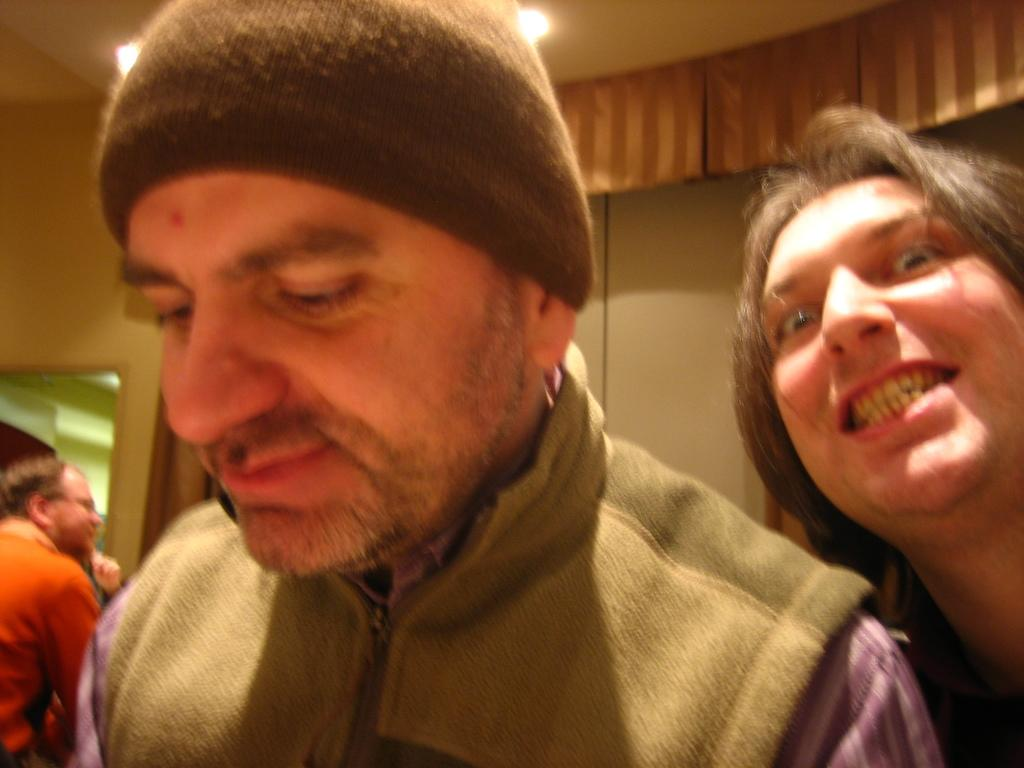What is the main subject of the image? The main subject of the image is a group of people. Can you describe the man in the middle of the image? The man in the middle of the image is wearing a cap. What can be seen in the background of the image? There are lights visible in the background of the image. What type of boot is the man wearing in the image? The man is not wearing a boot in the image; he is wearing a cap. Can you describe the root system of the plants in the image? There are no plants visible in the image, so it is not possible to describe their root system. 